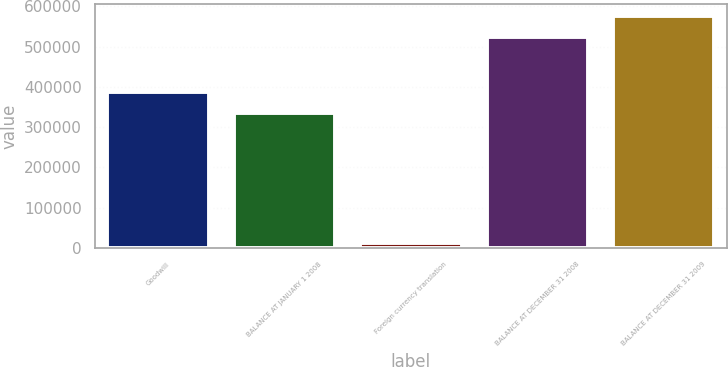Convert chart to OTSL. <chart><loc_0><loc_0><loc_500><loc_500><bar_chart><fcel>Goodwill<fcel>BALANCE AT JANUARY 1 2008<fcel>Foreign currency translation<fcel>BALANCE AT DECEMBER 31 2008<fcel>BALANCE AT DECEMBER 31 2009<nl><fcel>387076<fcel>334862<fcel>11841<fcel>524387<fcel>576601<nl></chart> 